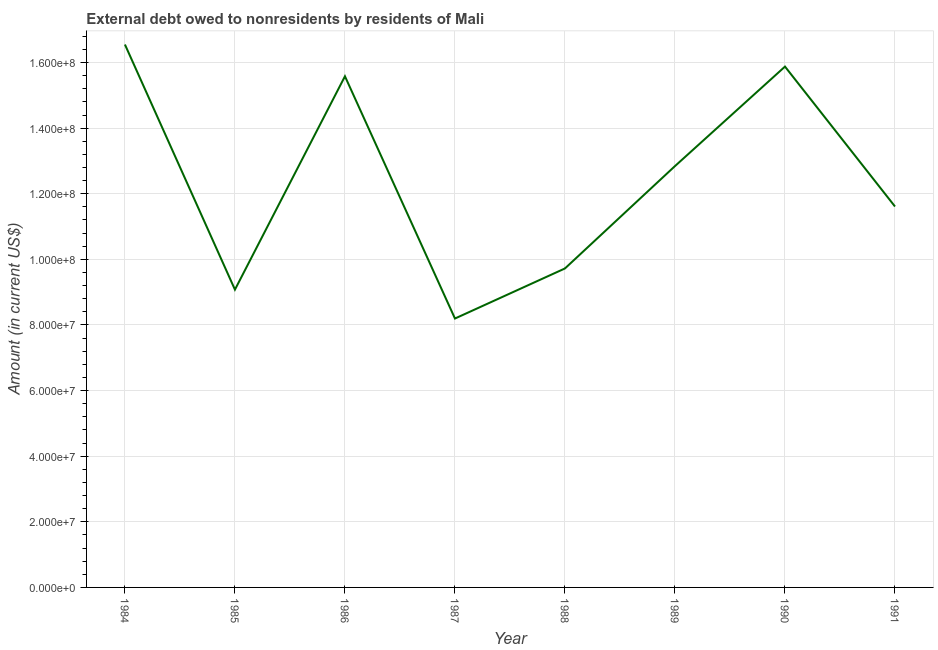What is the debt in 1985?
Provide a short and direct response. 9.08e+07. Across all years, what is the maximum debt?
Keep it short and to the point. 1.65e+08. Across all years, what is the minimum debt?
Keep it short and to the point. 8.20e+07. In which year was the debt minimum?
Your answer should be compact. 1987. What is the sum of the debt?
Give a very brief answer. 9.95e+08. What is the difference between the debt in 1986 and 1990?
Offer a very short reply. -2.95e+06. What is the average debt per year?
Keep it short and to the point. 1.24e+08. What is the median debt?
Keep it short and to the point. 1.22e+08. What is the ratio of the debt in 1988 to that in 1990?
Provide a short and direct response. 0.61. Is the debt in 1987 less than that in 1989?
Your response must be concise. Yes. Is the difference between the debt in 1984 and 1987 greater than the difference between any two years?
Provide a short and direct response. Yes. What is the difference between the highest and the second highest debt?
Your response must be concise. 6.73e+06. Is the sum of the debt in 1987 and 1990 greater than the maximum debt across all years?
Offer a very short reply. Yes. What is the difference between the highest and the lowest debt?
Your answer should be compact. 8.35e+07. In how many years, is the debt greater than the average debt taken over all years?
Your answer should be compact. 4. Does the debt monotonically increase over the years?
Keep it short and to the point. No. How many years are there in the graph?
Your answer should be compact. 8. What is the difference between two consecutive major ticks on the Y-axis?
Provide a succinct answer. 2.00e+07. Does the graph contain any zero values?
Provide a succinct answer. No. What is the title of the graph?
Provide a short and direct response. External debt owed to nonresidents by residents of Mali. What is the label or title of the Y-axis?
Ensure brevity in your answer.  Amount (in current US$). What is the Amount (in current US$) in 1984?
Provide a short and direct response. 1.65e+08. What is the Amount (in current US$) in 1985?
Provide a short and direct response. 9.08e+07. What is the Amount (in current US$) of 1986?
Ensure brevity in your answer.  1.56e+08. What is the Amount (in current US$) of 1987?
Ensure brevity in your answer.  8.20e+07. What is the Amount (in current US$) in 1988?
Your response must be concise. 9.72e+07. What is the Amount (in current US$) in 1989?
Keep it short and to the point. 1.28e+08. What is the Amount (in current US$) of 1990?
Offer a very short reply. 1.59e+08. What is the Amount (in current US$) of 1991?
Give a very brief answer. 1.16e+08. What is the difference between the Amount (in current US$) in 1984 and 1985?
Your answer should be compact. 7.47e+07. What is the difference between the Amount (in current US$) in 1984 and 1986?
Ensure brevity in your answer.  9.68e+06. What is the difference between the Amount (in current US$) in 1984 and 1987?
Make the answer very short. 8.35e+07. What is the difference between the Amount (in current US$) in 1984 and 1988?
Offer a terse response. 6.83e+07. What is the difference between the Amount (in current US$) in 1984 and 1989?
Offer a very short reply. 3.71e+07. What is the difference between the Amount (in current US$) in 1984 and 1990?
Offer a terse response. 6.73e+06. What is the difference between the Amount (in current US$) in 1984 and 1991?
Give a very brief answer. 4.94e+07. What is the difference between the Amount (in current US$) in 1985 and 1986?
Ensure brevity in your answer.  -6.50e+07. What is the difference between the Amount (in current US$) in 1985 and 1987?
Ensure brevity in your answer.  8.80e+06. What is the difference between the Amount (in current US$) in 1985 and 1988?
Your answer should be very brief. -6.46e+06. What is the difference between the Amount (in current US$) in 1985 and 1989?
Give a very brief answer. -3.77e+07. What is the difference between the Amount (in current US$) in 1985 and 1990?
Give a very brief answer. -6.80e+07. What is the difference between the Amount (in current US$) in 1985 and 1991?
Your answer should be very brief. -2.53e+07. What is the difference between the Amount (in current US$) in 1986 and 1987?
Make the answer very short. 7.38e+07. What is the difference between the Amount (in current US$) in 1986 and 1988?
Your answer should be very brief. 5.86e+07. What is the difference between the Amount (in current US$) in 1986 and 1989?
Give a very brief answer. 2.74e+07. What is the difference between the Amount (in current US$) in 1986 and 1990?
Your answer should be very brief. -2.95e+06. What is the difference between the Amount (in current US$) in 1986 and 1991?
Offer a terse response. 3.97e+07. What is the difference between the Amount (in current US$) in 1987 and 1988?
Keep it short and to the point. -1.53e+07. What is the difference between the Amount (in current US$) in 1987 and 1989?
Your response must be concise. -4.65e+07. What is the difference between the Amount (in current US$) in 1987 and 1990?
Give a very brief answer. -7.68e+07. What is the difference between the Amount (in current US$) in 1987 and 1991?
Ensure brevity in your answer.  -3.41e+07. What is the difference between the Amount (in current US$) in 1988 and 1989?
Your response must be concise. -3.12e+07. What is the difference between the Amount (in current US$) in 1988 and 1990?
Your answer should be compact. -6.15e+07. What is the difference between the Amount (in current US$) in 1988 and 1991?
Offer a terse response. -1.89e+07. What is the difference between the Amount (in current US$) in 1989 and 1990?
Provide a short and direct response. -3.03e+07. What is the difference between the Amount (in current US$) in 1989 and 1991?
Your response must be concise. 1.23e+07. What is the difference between the Amount (in current US$) in 1990 and 1991?
Offer a terse response. 4.26e+07. What is the ratio of the Amount (in current US$) in 1984 to that in 1985?
Ensure brevity in your answer.  1.82. What is the ratio of the Amount (in current US$) in 1984 to that in 1986?
Your response must be concise. 1.06. What is the ratio of the Amount (in current US$) in 1984 to that in 1987?
Offer a very short reply. 2.02. What is the ratio of the Amount (in current US$) in 1984 to that in 1988?
Your answer should be compact. 1.7. What is the ratio of the Amount (in current US$) in 1984 to that in 1989?
Your answer should be compact. 1.29. What is the ratio of the Amount (in current US$) in 1984 to that in 1990?
Keep it short and to the point. 1.04. What is the ratio of the Amount (in current US$) in 1984 to that in 1991?
Your answer should be very brief. 1.43. What is the ratio of the Amount (in current US$) in 1985 to that in 1986?
Provide a short and direct response. 0.58. What is the ratio of the Amount (in current US$) in 1985 to that in 1987?
Offer a terse response. 1.11. What is the ratio of the Amount (in current US$) in 1985 to that in 1988?
Offer a terse response. 0.93. What is the ratio of the Amount (in current US$) in 1985 to that in 1989?
Offer a very short reply. 0.71. What is the ratio of the Amount (in current US$) in 1985 to that in 1990?
Give a very brief answer. 0.57. What is the ratio of the Amount (in current US$) in 1985 to that in 1991?
Your answer should be very brief. 0.78. What is the ratio of the Amount (in current US$) in 1986 to that in 1987?
Ensure brevity in your answer.  1.9. What is the ratio of the Amount (in current US$) in 1986 to that in 1988?
Give a very brief answer. 1.6. What is the ratio of the Amount (in current US$) in 1986 to that in 1989?
Keep it short and to the point. 1.21. What is the ratio of the Amount (in current US$) in 1986 to that in 1991?
Give a very brief answer. 1.34. What is the ratio of the Amount (in current US$) in 1987 to that in 1988?
Keep it short and to the point. 0.84. What is the ratio of the Amount (in current US$) in 1987 to that in 1989?
Offer a terse response. 0.64. What is the ratio of the Amount (in current US$) in 1987 to that in 1990?
Give a very brief answer. 0.52. What is the ratio of the Amount (in current US$) in 1987 to that in 1991?
Offer a terse response. 0.71. What is the ratio of the Amount (in current US$) in 1988 to that in 1989?
Provide a succinct answer. 0.76. What is the ratio of the Amount (in current US$) in 1988 to that in 1990?
Provide a succinct answer. 0.61. What is the ratio of the Amount (in current US$) in 1988 to that in 1991?
Keep it short and to the point. 0.84. What is the ratio of the Amount (in current US$) in 1989 to that in 1990?
Offer a very short reply. 0.81. What is the ratio of the Amount (in current US$) in 1989 to that in 1991?
Your answer should be very brief. 1.11. What is the ratio of the Amount (in current US$) in 1990 to that in 1991?
Give a very brief answer. 1.37. 